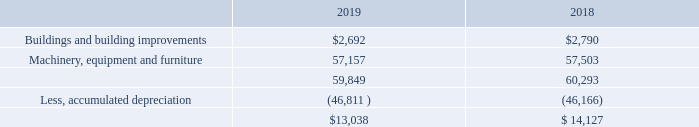7. Property, Plant and Equipment and Leases
Property, plant and equipment at April 30, 2019 and 2018, consisted of the following (in thousands):
Depreciation and amortization expense for the years ended April 30, 2019 and 2018 was $2,802,000 and $2,484,000, respectively.
Maintenance and repairs charged to operations for the years ended April 30, 2019 and 2018 was approximately $309,000 and $466,000, respectively.
The Company leases its Long Island, New York headquarters building. On July 25, 2018, the Company signed an amendment to the lease which extends the current lease terms ten years and eight months through September 30, 2029. Pursuant to the amendment to the lease agreement, the annual rent will increase from $1,046,810 in 2019 to $1,276,056 in 2029. Under the terms of the lease, the Company is required to pay its proportionate share of real estate taxes, insurance and other charges.
In addition, the Company’s subsidiaries in New Jersey and California lease their office and manufacturing facilities. On February 1, 2018, FEI-Elcom entered into a new lease agreement in New Jersey for office and manufacturing space encompassing approximately 9,000 square feet. The monthly rent is $9,673 through the end of the lease which expires in January 31, 2021. FEI-Zyfer has signed a second amendment to its lease in California, which extends the lease an additional 88 months, beginning October 1, 2017 and expiring January 31, 2025. The average annual rent over the period of the amendment is approximately $312,000. FEI-Zyfer leases office and manufacturing space encompassing 27,850 square feet.
Rent expense under operating leases for the years ended April 30, 2019 and 2018 was approximately $1.2 million and $1.7 million, respectively. The Company records rent expense on its New York building and FEI-Zyfer facility on the straight-line method over the lives of the respective leases. As a result, as of April 30, 2019 and 2018, the Company’s Consolidated Balance Sheet included deferred rent payable of approximately $236,000 and $110,000, respectively, which will be recognized over the respective rental periods.
What is the amount of maintenance and repairs charged to operations for 2019 and 2018 respectively? $309,000, $466,000. What is the depreciation and amortization expense for 2019 and 2018 respectively? $2,802,000, $2,484,000. What is the amount of buildings and building improvements in 2019 and 2018 respectively?
Answer scale should be: thousand. $2,692, $2,790. What is the average value of buildings and building improvements in 2018 and 2019?
Answer scale should be: thousand. (2,692+2,790)/2
Answer: 2741. What is the change between the value of machinery, equipment and furniture between 2018 and 2019?
Answer scale should be: thousand. 57,157-57,503
Answer: -346. What is the total maintenance and repairs charged to operations for 2018 and 2019? 309,000+466,000
Answer: 775000. 